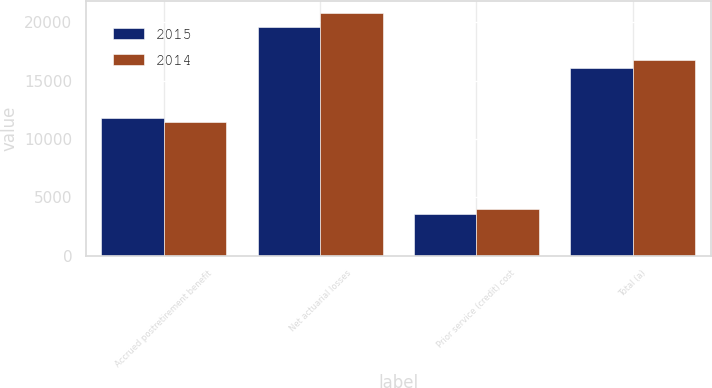Convert chart. <chart><loc_0><loc_0><loc_500><loc_500><stacked_bar_chart><ecel><fcel>Accrued postretirement benefit<fcel>Net actuarial losses<fcel>Prior service (credit) cost<fcel>Total (a)<nl><fcel>2015<fcel>11807<fcel>19632<fcel>3565<fcel>16067<nl><fcel>2014<fcel>11413<fcel>20794<fcel>3985<fcel>16809<nl></chart> 